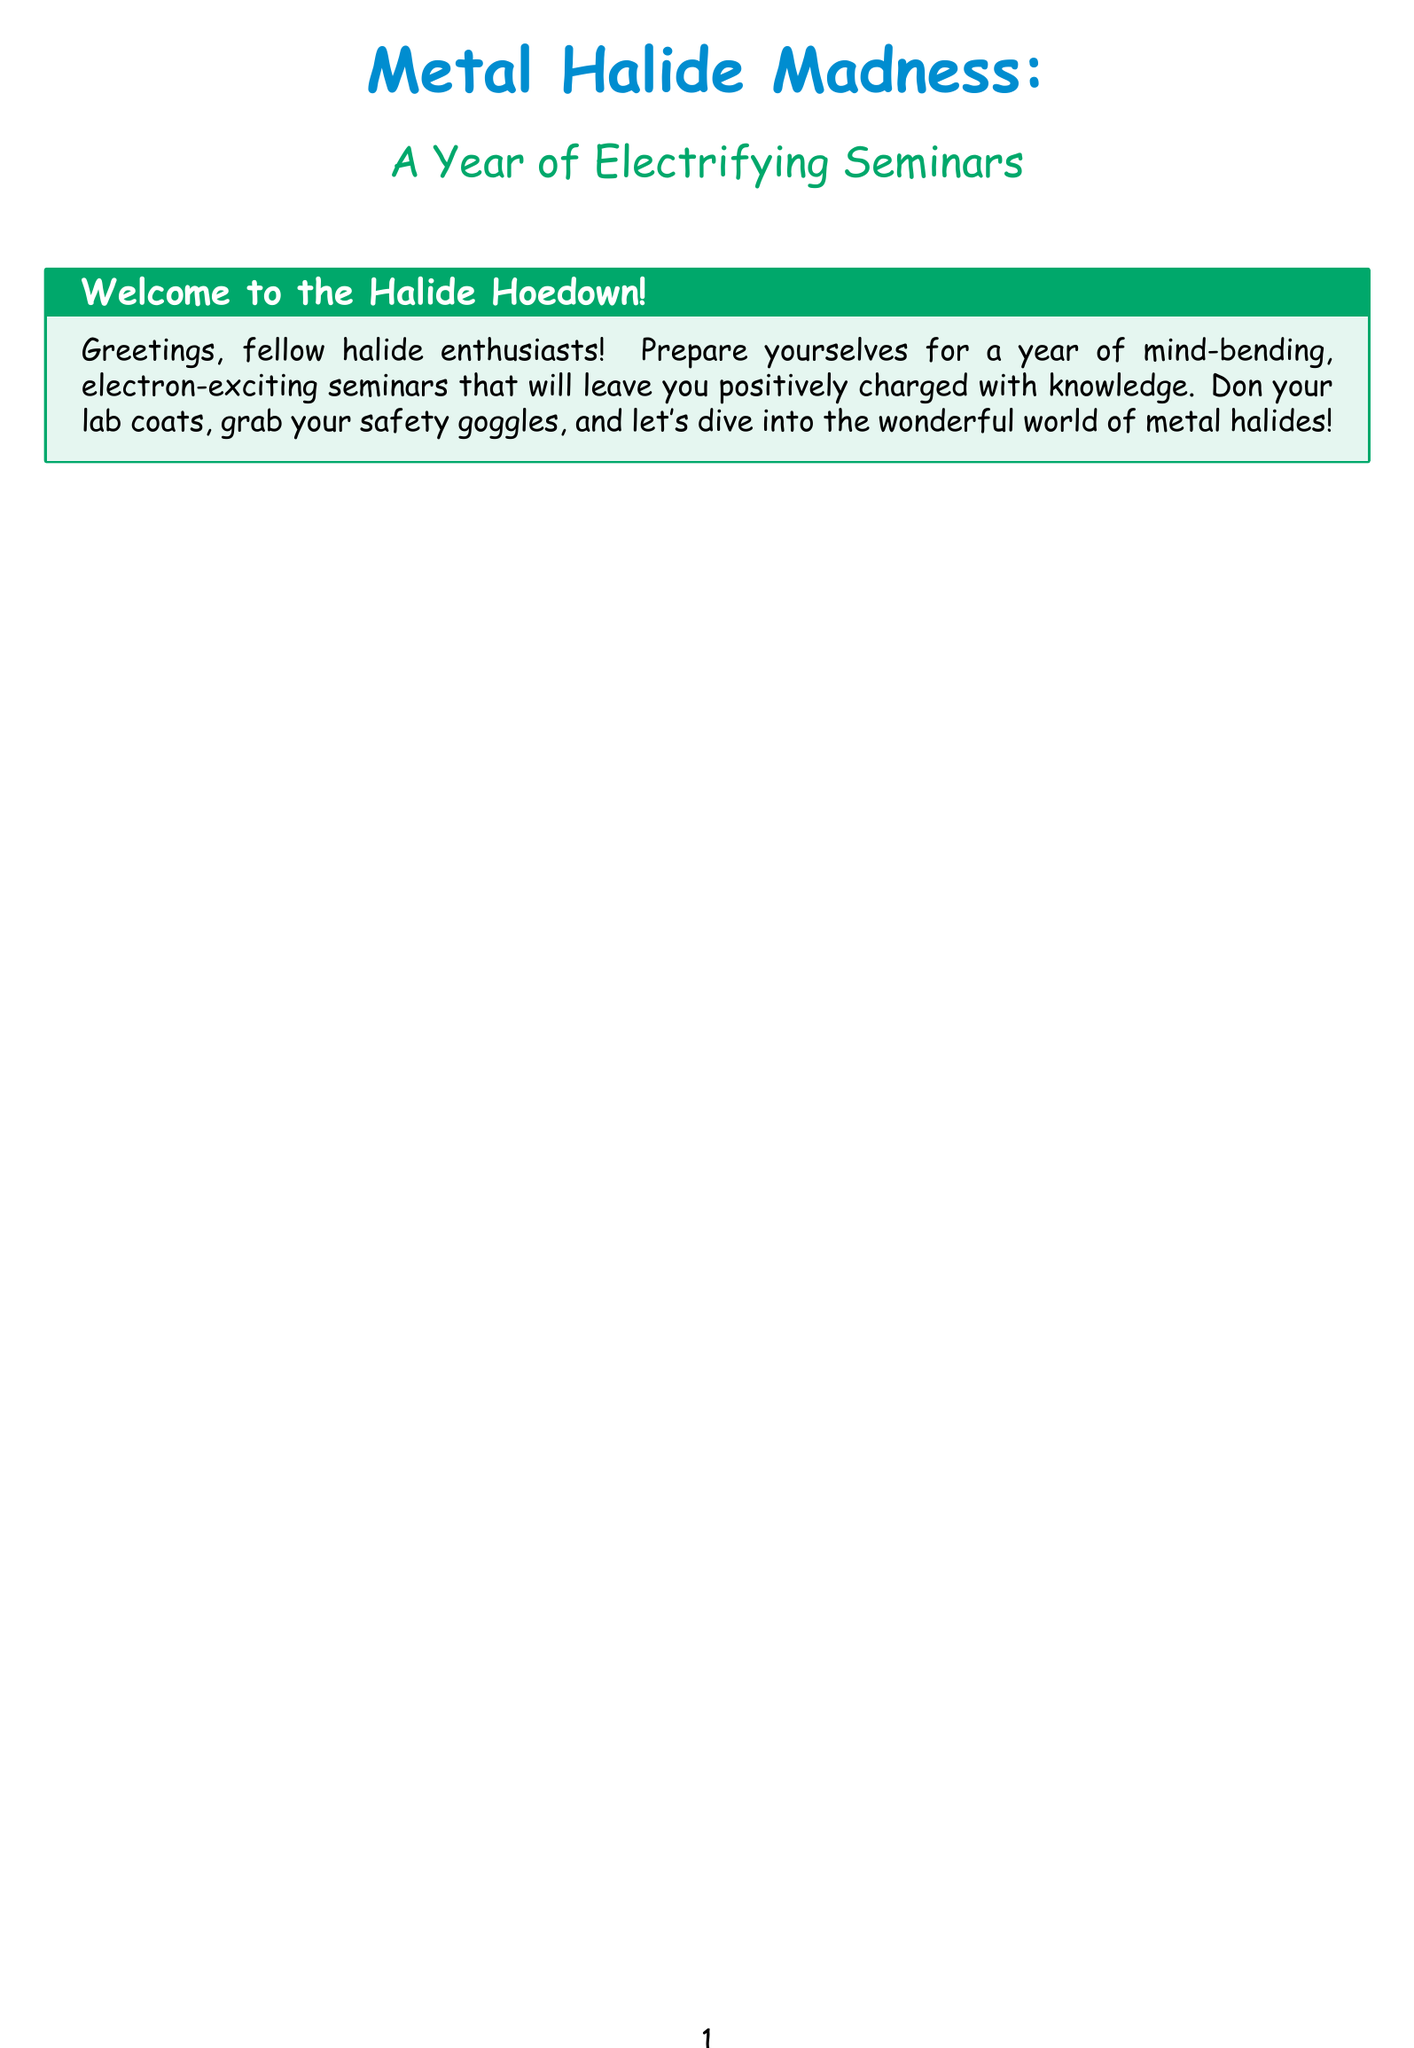What is the topic of the seminar in January? The topic of the January seminar is highlighted as "Metal Halides in Catalysis: The Ziegler-Natta Revolution."
Answer: Metal Halides in Catalysis: The Ziegler-Natta Revolution Who is the speaker for the February seminar? The February seminar features Prof. Hiroshi Tanaka from the University of Tokyo as the speaker.
Answer: Prof. Hiroshi Tanaka What is the main theme of the seminar in April? The seminar in April focuses on "Metal Halides in Nuclear Fuel Reprocessing: Molten Salt Madness."
Answer: Metal Halides in Nuclear Fuel Reprocessing: Molten Salt Madness Which month covers the topic of "Halide Perovskites in Quantum Computing"? The seminar on "Halide Perovskites in Quantum Computing" is scheduled for November.
Answer: November How many seminars are scheduled for the year? By counting each monthly seminar listed, there are 12 seminars scheduled in total.
Answer: 12 What common element is discussed in both the July and November seminars? Both the July and November seminars discuss halide perovskites in their respective topics.
Answer: Halide Perovskites What safety equipment is mentioned for the seminar in April? The document emphasizes the need for safety goggles during the April seminar on molten salt mixtures.
Answer: Safety goggles Which seminar describes the properties of ionic liquids? The seminar that discusses the properties of ionic liquids is in May, focusing on "Halometallate Ionic Liquids."
Answer: Halometallate Ionic Liquids What type of materials are used in the September seminar's application? The September seminar discusses the application of titanium tetrachloride in vapor deposition.
Answer: Titanium tetrachloride 